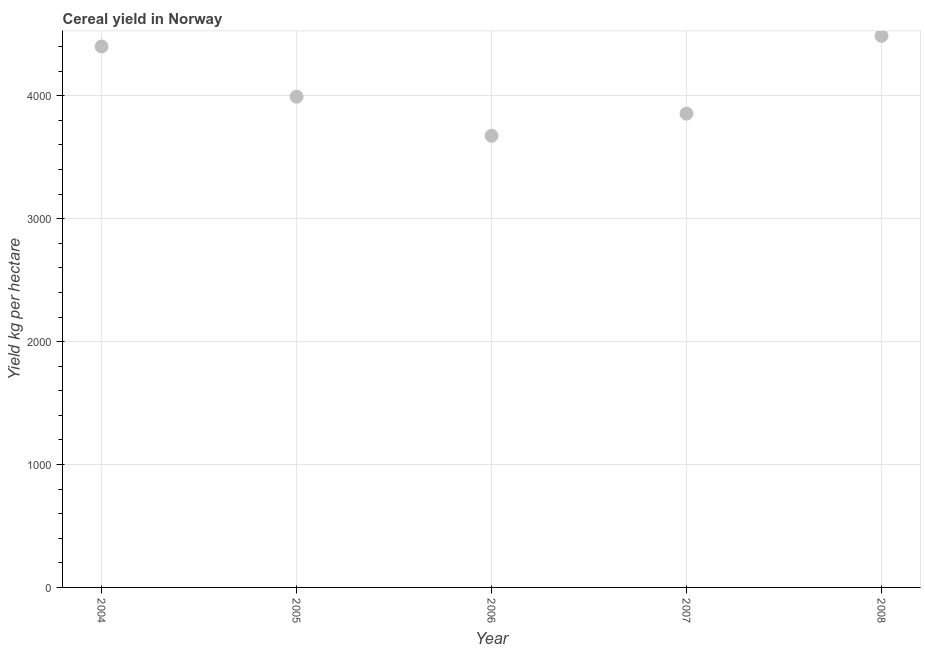What is the cereal yield in 2004?
Make the answer very short. 4401.48. Across all years, what is the maximum cereal yield?
Offer a very short reply. 4488.05. Across all years, what is the minimum cereal yield?
Offer a terse response. 3674.47. In which year was the cereal yield maximum?
Make the answer very short. 2008. What is the sum of the cereal yield?
Ensure brevity in your answer.  2.04e+04. What is the difference between the cereal yield in 2004 and 2007?
Provide a succinct answer. 546.46. What is the average cereal yield per year?
Offer a terse response. 4082.33. What is the median cereal yield?
Keep it short and to the point. 3992.62. In how many years, is the cereal yield greater than 1000 kg per hectare?
Make the answer very short. 5. What is the ratio of the cereal yield in 2005 to that in 2008?
Make the answer very short. 0.89. What is the difference between the highest and the second highest cereal yield?
Offer a very short reply. 86.56. What is the difference between the highest and the lowest cereal yield?
Make the answer very short. 813.58. In how many years, is the cereal yield greater than the average cereal yield taken over all years?
Your response must be concise. 2. Does the cereal yield monotonically increase over the years?
Offer a terse response. No. How many dotlines are there?
Keep it short and to the point. 1. Are the values on the major ticks of Y-axis written in scientific E-notation?
Your response must be concise. No. Does the graph contain grids?
Your response must be concise. Yes. What is the title of the graph?
Keep it short and to the point. Cereal yield in Norway. What is the label or title of the Y-axis?
Provide a short and direct response. Yield kg per hectare. What is the Yield kg per hectare in 2004?
Offer a terse response. 4401.48. What is the Yield kg per hectare in 2005?
Offer a very short reply. 3992.62. What is the Yield kg per hectare in 2006?
Offer a very short reply. 3674.47. What is the Yield kg per hectare in 2007?
Provide a succinct answer. 3855.02. What is the Yield kg per hectare in 2008?
Give a very brief answer. 4488.05. What is the difference between the Yield kg per hectare in 2004 and 2005?
Ensure brevity in your answer.  408.86. What is the difference between the Yield kg per hectare in 2004 and 2006?
Make the answer very short. 727.01. What is the difference between the Yield kg per hectare in 2004 and 2007?
Your response must be concise. 546.46. What is the difference between the Yield kg per hectare in 2004 and 2008?
Keep it short and to the point. -86.56. What is the difference between the Yield kg per hectare in 2005 and 2006?
Your answer should be compact. 318.15. What is the difference between the Yield kg per hectare in 2005 and 2007?
Ensure brevity in your answer.  137.6. What is the difference between the Yield kg per hectare in 2005 and 2008?
Your response must be concise. -495.43. What is the difference between the Yield kg per hectare in 2006 and 2007?
Provide a short and direct response. -180.55. What is the difference between the Yield kg per hectare in 2006 and 2008?
Your answer should be very brief. -813.58. What is the difference between the Yield kg per hectare in 2007 and 2008?
Make the answer very short. -633.02. What is the ratio of the Yield kg per hectare in 2004 to that in 2005?
Your response must be concise. 1.1. What is the ratio of the Yield kg per hectare in 2004 to that in 2006?
Make the answer very short. 1.2. What is the ratio of the Yield kg per hectare in 2004 to that in 2007?
Provide a succinct answer. 1.14. What is the ratio of the Yield kg per hectare in 2005 to that in 2006?
Provide a short and direct response. 1.09. What is the ratio of the Yield kg per hectare in 2005 to that in 2007?
Ensure brevity in your answer.  1.04. What is the ratio of the Yield kg per hectare in 2005 to that in 2008?
Keep it short and to the point. 0.89. What is the ratio of the Yield kg per hectare in 2006 to that in 2007?
Your answer should be very brief. 0.95. What is the ratio of the Yield kg per hectare in 2006 to that in 2008?
Your answer should be compact. 0.82. What is the ratio of the Yield kg per hectare in 2007 to that in 2008?
Your answer should be very brief. 0.86. 